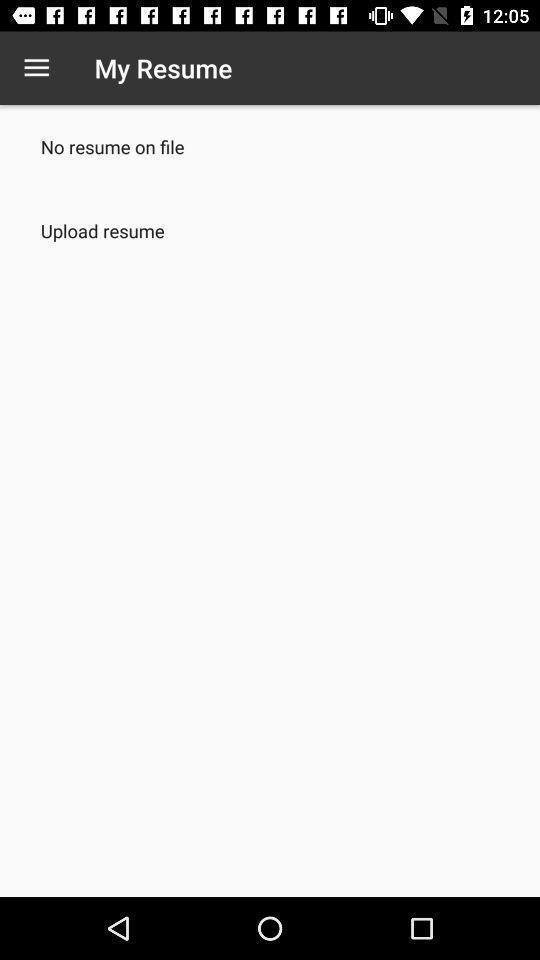Give me a summary of this screen capture. Screen displaying upload resume. 